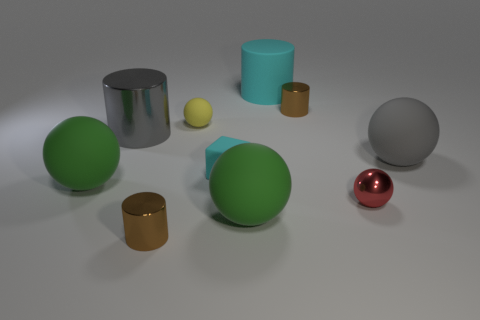Does the big metallic thing have the same shape as the small red object?
Offer a terse response. No. How many objects are big rubber balls that are on the right side of the red object or gray metallic objects?
Provide a succinct answer. 2. There is a red object that is made of the same material as the large gray cylinder; what size is it?
Your response must be concise. Small. How many shiny objects have the same color as the small metal sphere?
Ensure brevity in your answer.  0. What number of large things are either gray matte balls or cyan matte cylinders?
Your response must be concise. 2. The block that is the same color as the matte cylinder is what size?
Make the answer very short. Small. Are there any gray spheres that have the same material as the red object?
Offer a terse response. No. What is the brown cylinder that is to the right of the rubber cylinder made of?
Keep it short and to the point. Metal. Does the tiny shiny object on the left side of the cyan rubber cylinder have the same color as the big cylinder on the left side of the yellow matte sphere?
Provide a succinct answer. No. The rubber ball that is the same size as the cyan matte cube is what color?
Your answer should be compact. Yellow. 